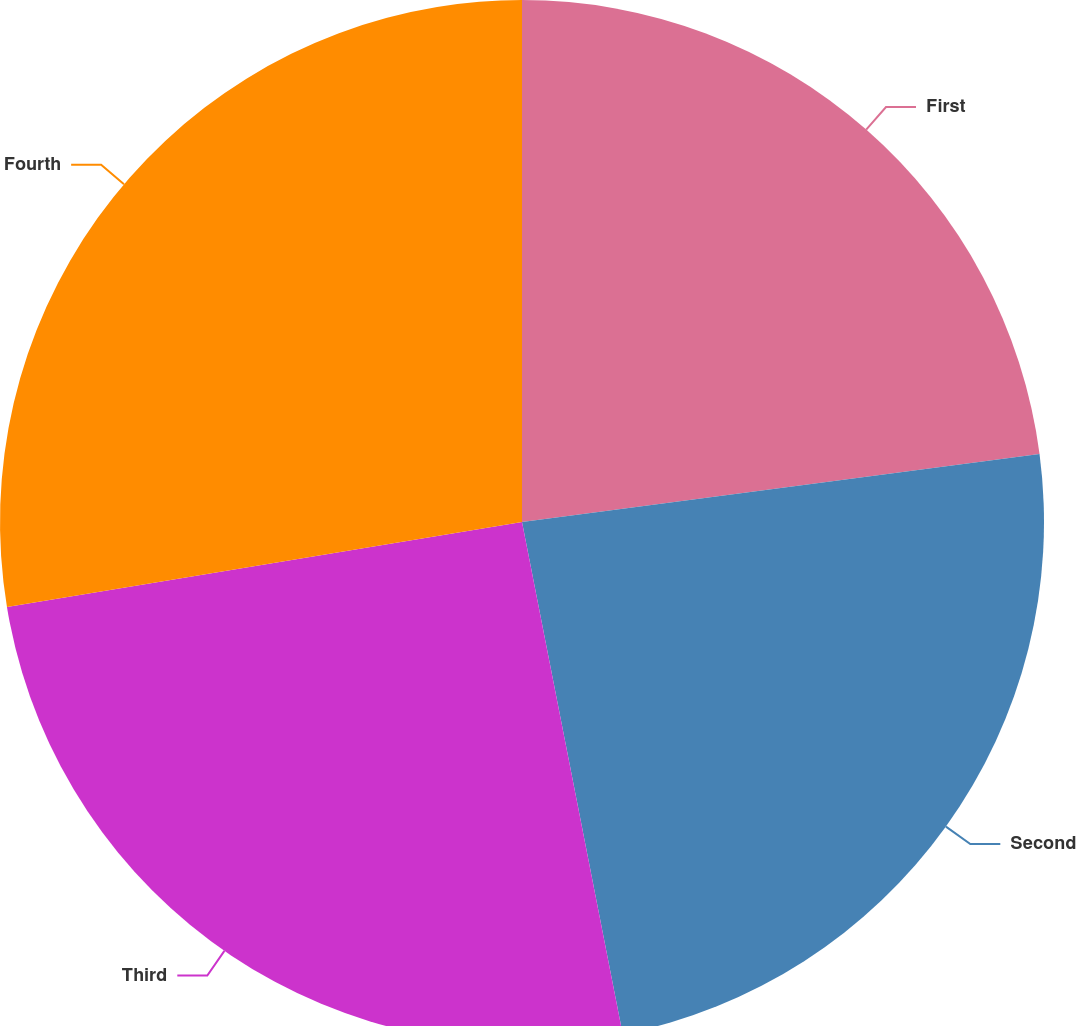<chart> <loc_0><loc_0><loc_500><loc_500><pie_chart><fcel>First<fcel>Second<fcel>Third<fcel>Fourth<nl><fcel>22.92%<fcel>23.99%<fcel>25.49%<fcel>27.6%<nl></chart> 